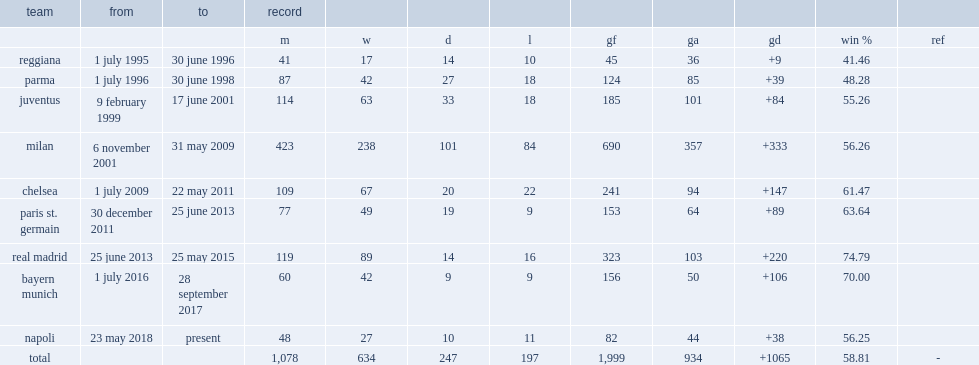How many games did ancelotti led milan for? 423.0. 